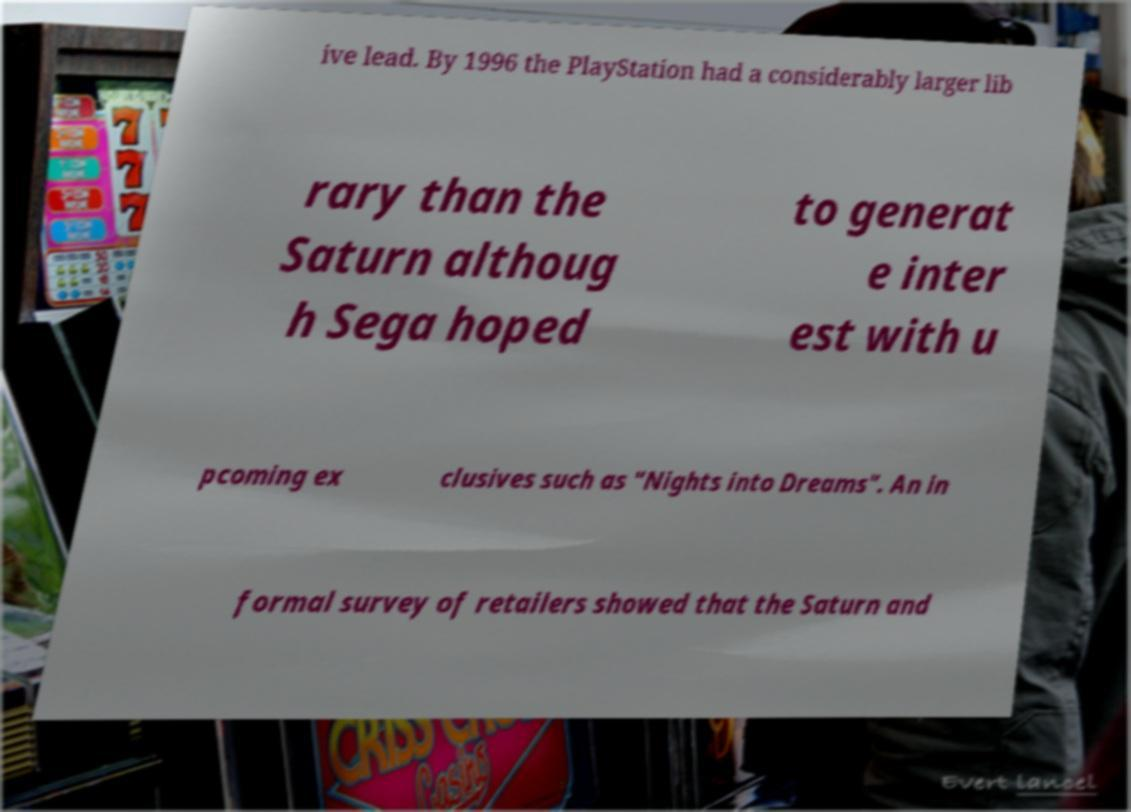For documentation purposes, I need the text within this image transcribed. Could you provide that? ive lead. By 1996 the PlayStation had a considerably larger lib rary than the Saturn althoug h Sega hoped to generat e inter est with u pcoming ex clusives such as "Nights into Dreams". An in formal survey of retailers showed that the Saturn and 